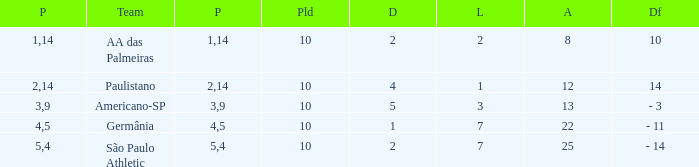What is the sum of Against when the lost is more than 7? None. 